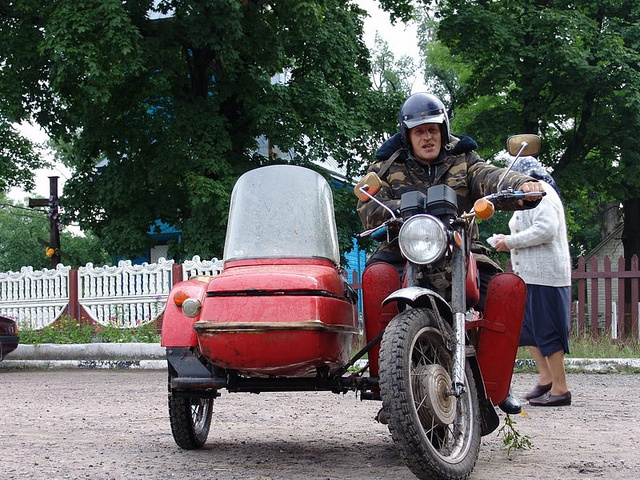Describe the objects in this image and their specific colors. I can see motorcycle in black, gray, darkgray, and lightgray tones, people in black, lightgray, darkgray, and gray tones, people in black, gray, and darkgray tones, and car in black and gray tones in this image. 